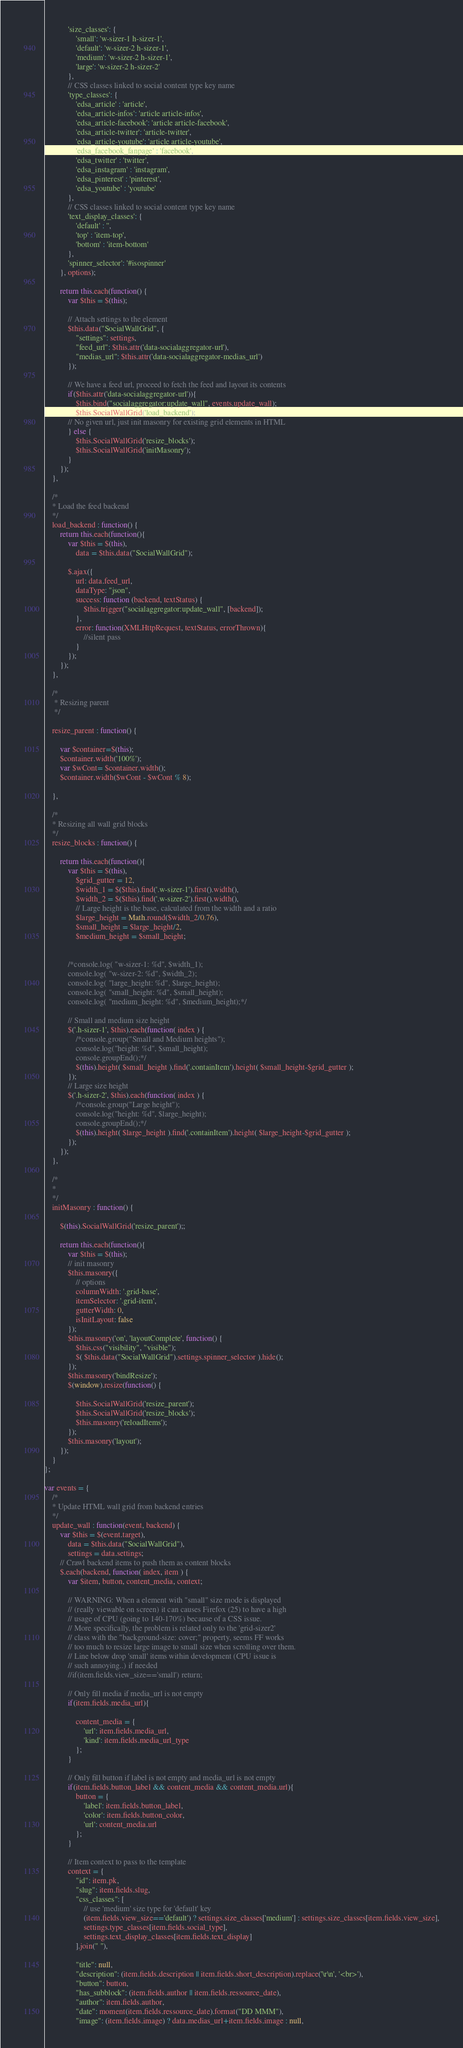<code> <loc_0><loc_0><loc_500><loc_500><_JavaScript_>            'size_classes': {
                'small': 'w-sizer-1 h-sizer-1',
                'default': 'w-sizer-2 h-sizer-1',
                'medium': 'w-sizer-2 h-sizer-1',
                'large': 'w-sizer-2 h-sizer-2'
            },
            // CSS classes linked to social content type key name
            'type_classes': {
                'edsa_article' : 'article',
                'edsa_article-infos': 'article article-infos',
                'edsa_article-facebook': 'article article-facebook',
                'edsa_article-twitter': 'article-twitter',
                'edsa_article-youtube': 'article article-youtube',
                'edsa_facebook_fanpage' : 'facebook',
                'edsa_twitter' : 'twitter',
                'edsa_instagram' : 'instagram',
                'edsa_pinterest' : 'pinterest',
                'edsa_youtube' : 'youtube'
            },
            // CSS classes linked to social content type key name
            'text_display_classes': {
                'default' : '',
                'top' : 'item-top',
                'bottom' : 'item-bottom'
            },
            'spinner_selector': '#isospinner'
        }, options);
        
        return this.each(function() {
            var $this = $(this);
            
            // Attach settings to the element
            $this.data("SocialWallGrid", {
                "settings": settings,
                "feed_url": $this.attr('data-socialaggregator-url'),
                "medias_url": $this.attr('data-socialaggregator-medias_url')
            });
            
            // We have a feed url, proceed to fetch the feed and layout its contents
            if($this.attr('data-socialaggregator-url')){
                $this.bind("socialaggregator:update_wall", events.update_wall);
                $this.SocialWallGrid('load_backend');
            // No given url, just init masonry for existing grid elements in HTML
            } else {
                $this.SocialWallGrid('resize_blocks');
                $this.SocialWallGrid('initMasonry');
            }
        });
    },
 
    /*
    * Load the feed backend
    */
    load_backend : function() {
        return this.each(function(){
            var $this = $(this),
                data = $this.data("SocialWallGrid");
            
            $.ajax({
                url: data.feed_url,
                dataType: "json",
                success: function (backend, textStatus) {
                    $this.trigger("socialaggregator:update_wall", [backend]);
                },
                error: function(XMLHttpRequest, textStatus, errorThrown){
                    //silent pass
                }
            });
        });
    },

    /*
     * Resizing parent
     */

    resize_parent : function() {

        var $container=$(this);
        $container.width('100%');
        var $wCont= $container.width();
        $container.width($wCont - $wCont % 8);

    },

    /*
    * Resizing all wall grid blocks
    */
    resize_blocks : function() {

        return this.each(function(){
            var $this = $(this),
                $grid_gutter = 12,
                $width_1 = $($this).find('.w-sizer-1').first().width(),
                $width_2 = $($this).find('.w-sizer-2').first().width(),
                // Large height is the base, calculated from the width and a ratio
                $large_height = Math.round($width_2/0.76),
                $small_height = $large_height/2,
                $medium_height = $small_height;

            
            /*console.log( "w-sizer-1: %d", $width_1);
            console.log( "w-sizer-2: %d", $width_2);
            console.log( "large_height: %d", $large_height);
            console.log( "small_height: %d", $small_height);
            console.log( "medium_height: %d", $medium_height);*/
            
            // Small and medium size height
            $('.h-sizer-1', $this).each(function( index ) {
                /*console.group("Small and Medium heights");
                console.log("height: %d", $small_height);
                console.groupEnd();*/
                $(this).height( $small_height ).find('.containItem').height( $small_height-$grid_gutter );
            });
            // Large size height
            $('.h-sizer-2', $this).each(function( index ) {
                /*console.group("Large height");
                console.log("height: %d", $large_height);
                console.groupEnd();*/
                $(this).height( $large_height ).find('.containItem').height( $large_height-$grid_gutter );
            });
        });
    },

    /*
    * 
    */
    initMasonry : function() {

        $(this).SocialWallGrid('resize_parent');;

        return this.each(function(){
            var $this = $(this);
            // init masonry
            $this.masonry({
                // options
                columnWidth: '.grid-base',
                itemSelector: '.grid-item',
                gutterWidth: 0,
                isInitLayout: false
            });
            $this.masonry('on', 'layoutComplete', function() {
                $this.css("visibility", "visible");
                $( $this.data("SocialWallGrid").settings.spinner_selector ).hide();
            });
            $this.masonry('bindResize');
            $(window).resize(function() {

                $this.SocialWallGrid('resize_parent');
                $this.SocialWallGrid('resize_blocks');
                $this.masonry('reloadItems');
            });
            $this.masonry('layout');
        });
    }
};

var events = {
    /*
    * Update HTML wall grid from backend entries
    */
    update_wall : function(event, backend) {
        var $this = $(event.target),
            data = $this.data("SocialWallGrid"),
            settings = data.settings;
        // Crawl backend items to push them as content blocks
        $.each(backend, function( index, item ) {
            var $item, button, content_media, context;
            
            // WARNING: When a element with "small" size mode is displayed 
            // (really viewable on screen) it can causes Firefox (25) to have a high 
            // usage of CPU (going to 140-170%) because of a CSS issue.
            // More specifically, the problem is related only to the 'grid-sizer2' 
            // class with the "background-size: cover;" property, seems FF works 
            // too much to resize large image to small size when scrolling over them.
            // Line below drop 'small' items within development (CPU issue is 
            // such annoying..) if needed
            //if(item.fields.view_size=='small') return;

            // Only fill media if media_url is not empty
            if(item.fields.media_url){
                
                content_media = {
                    'url': item.fields.media_url,
                    'kind': item.fields.media_url_type
                };
            }
            
            // Only fill button if label is not empty and media_url is not empty
            if(item.fields.button_label && content_media && content_media.url){
                button = {
                    'label': item.fields.button_label,
                    'color': item.fields.button_color,
                    'url': content_media.url
                };
            }
            
            // Item context to pass to the template
            context = {
                "id": item.pk,
                "slug": item.fields.slug,
                "css_classes": [
                    // use 'medium' size type for 'default' key
                    (item.fields.view_size=='default') ? settings.size_classes['medium'] : settings.size_classes[item.fields.view_size],
                    settings.type_classes[item.fields.social_type],
                    settings.text_display_classes[item.fields.text_display]
                ].join(" "),
               
                "title": null,
                "description": (item.fields.description || item.fields.short_description).replace('\r\n', '<br>'),
                "button": button,
                "has_subblock": (item.fields.author || item.fields.ressource_date),
                "author": item.fields.author,
                "date": moment(item.fields.ressource_date).format("DD MMM"),
                "image": (item.fields.image) ? data.medias_url+item.fields.image : null,</code> 